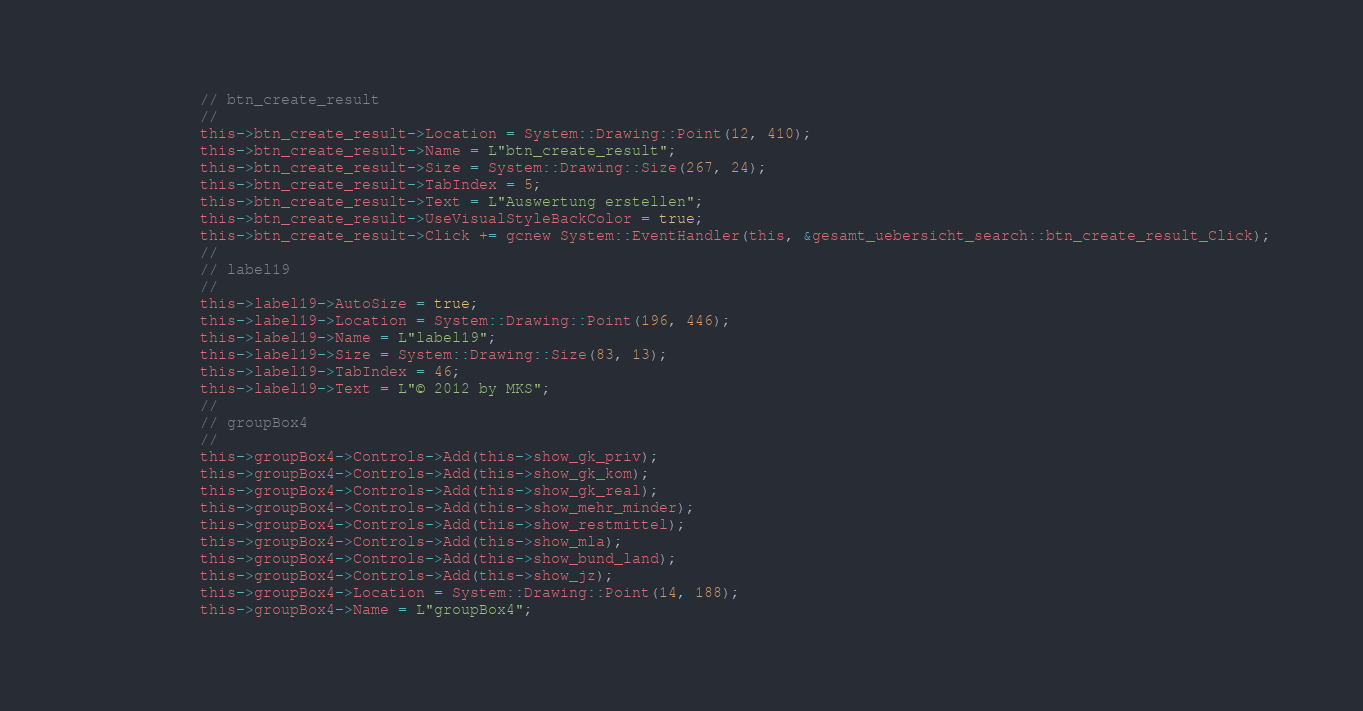<code> <loc_0><loc_0><loc_500><loc_500><_C_>			// btn_create_result
			// 
			this->btn_create_result->Location = System::Drawing::Point(12, 410);
			this->btn_create_result->Name = L"btn_create_result";
			this->btn_create_result->Size = System::Drawing::Size(267, 24);
			this->btn_create_result->TabIndex = 5;
			this->btn_create_result->Text = L"Auswertung erstellen";
			this->btn_create_result->UseVisualStyleBackColor = true;
			this->btn_create_result->Click += gcnew System::EventHandler(this, &gesamt_uebersicht_search::btn_create_result_Click);
			// 
			// label19
			// 
			this->label19->AutoSize = true;
			this->label19->Location = System::Drawing::Point(196, 446);
			this->label19->Name = L"label19";
			this->label19->Size = System::Drawing::Size(83, 13);
			this->label19->TabIndex = 46;
			this->label19->Text = L"© 2012 by MKS";
			// 
			// groupBox4
			// 
			this->groupBox4->Controls->Add(this->show_gk_priv);
			this->groupBox4->Controls->Add(this->show_gk_kom);
			this->groupBox4->Controls->Add(this->show_gk_real);
			this->groupBox4->Controls->Add(this->show_mehr_minder);
			this->groupBox4->Controls->Add(this->show_restmittel);
			this->groupBox4->Controls->Add(this->show_mla);
			this->groupBox4->Controls->Add(this->show_bund_land);
			this->groupBox4->Controls->Add(this->show_jz);
			this->groupBox4->Location = System::Drawing::Point(14, 188);
			this->groupBox4->Name = L"groupBox4";</code> 